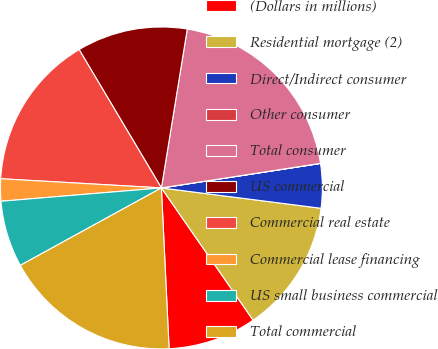Convert chart. <chart><loc_0><loc_0><loc_500><loc_500><pie_chart><fcel>(Dollars in millions)<fcel>Residential mortgage (2)<fcel>Direct/Indirect consumer<fcel>Other consumer<fcel>Total consumer<fcel>US commercial<fcel>Commercial real estate<fcel>Commercial lease financing<fcel>US small business commercial<fcel>Total commercial<nl><fcel>8.89%<fcel>13.33%<fcel>4.45%<fcel>0.01%<fcel>19.99%<fcel>11.11%<fcel>15.55%<fcel>2.23%<fcel>6.67%<fcel>17.77%<nl></chart> 